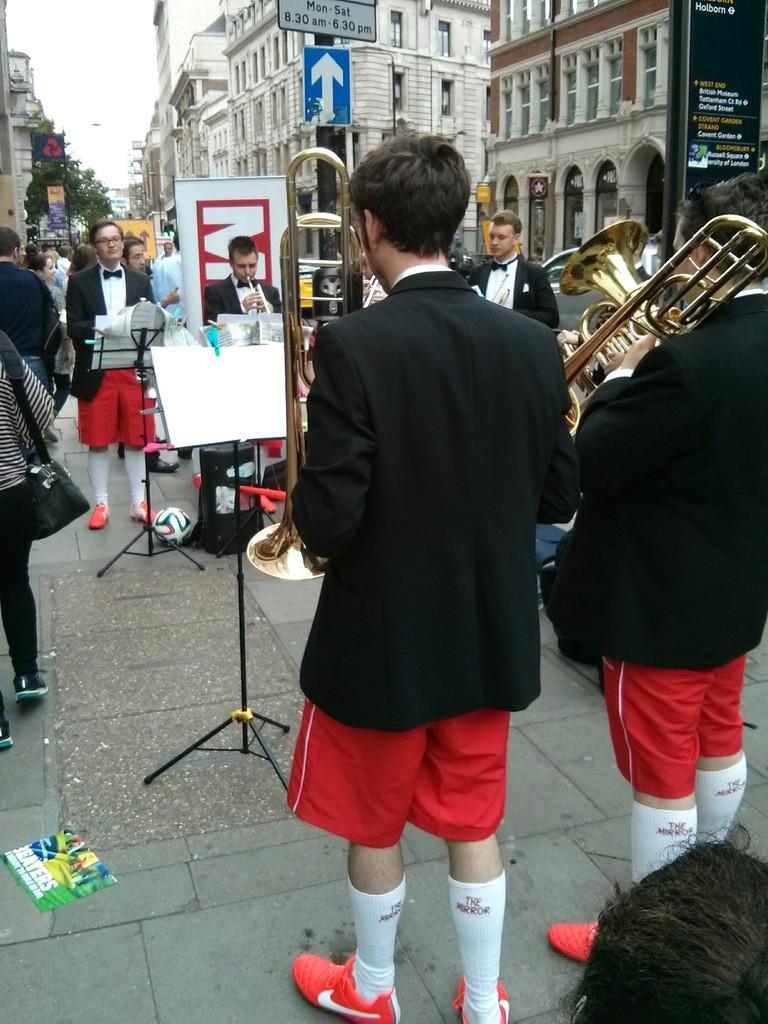In one or two sentences, can you explain what this image depicts? This image is taken outdoors. At the bottom of the image there is a floor. In the background there are many buildings. There are two trees. There are many boards with text on them. There are two signboards. There is a banner with a text on it. A few vehicles are moving on the road. In the middle of the image many people are standing on the sidewalk and playing music. They are holding musical instruments in their hands. There are two strands with notes on them. A few people are walking on the sidewalk. 